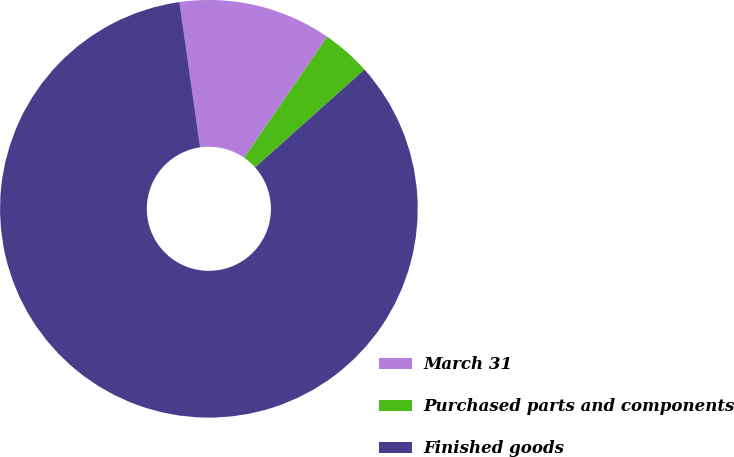Convert chart to OTSL. <chart><loc_0><loc_0><loc_500><loc_500><pie_chart><fcel>March 31<fcel>Purchased parts and components<fcel>Finished goods<nl><fcel>11.84%<fcel>3.79%<fcel>84.37%<nl></chart> 